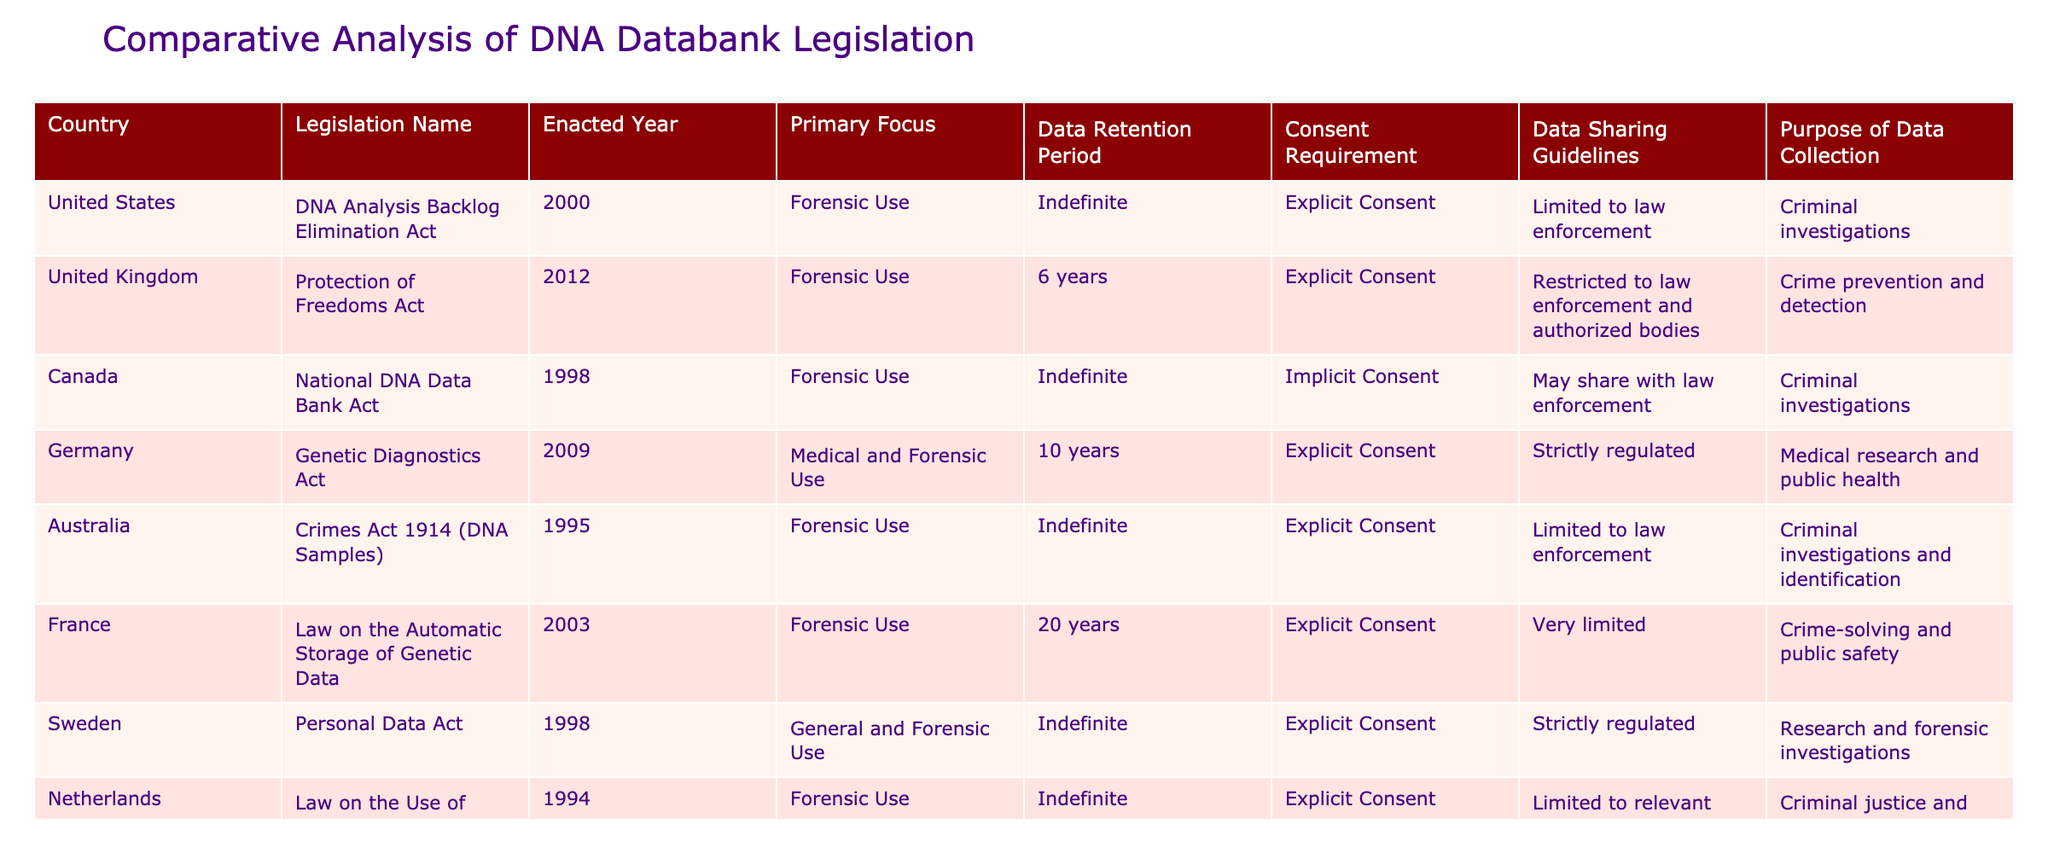What is the data retention period in Germany? In the table, the data retention period for Germany is listed in the "Data Retention Period" column. It shows "10 years."
Answer: 10 years Which countries require explicit consent for DNA data collection? By reviewing the "Consent Requirement" column, we can identify the countries listed as requiring "Explicit Consent." These countries are the United States, United Kingdom, Germany, Australia, France, Sweden, Netherlands, India, and South Africa. Counting these provides a total of 9 countries.
Answer: 9 countries What is the average data retention period for the provided countries? We sum the data retention periods from the table. These are: Indefinite (assume 100 years for calculation), 6 years, Indefinite (100 years), 10 years, Indefinite (100 years), 20 years, Indefinite (100 years), Indefinite (100 years), Indefinite (100 years). The sum is 100 + 6 + 100 + 10 + 100 + 20 + 100 + 100 + 100 = 736. There are 9 entries, so we divide 736 by 9, which gives approximately 81.78 years.
Answer: Approximately 81.78 years Is there any country in the table that allows data sharing beyond law enforcement? We check the "Data Sharing Guidelines" column for any mention of data sharing that exceeds law enforcement. The analysis reveals that Canada may share with law enforcement and India controls sharing through a regulatory body, but there is no explicit mention of sharing beyond law enforcement in a general sense. Therefore, the answer is no.
Answer: No Which country collects DNA data for both medical and forensic use? In the "Primary Focus" column, we look for the description that indicates both medical and forensic use. Only Germany mentions "Medical and Forensic Use" as its focus. Thus, Germany is the answer.
Answer: Germany 